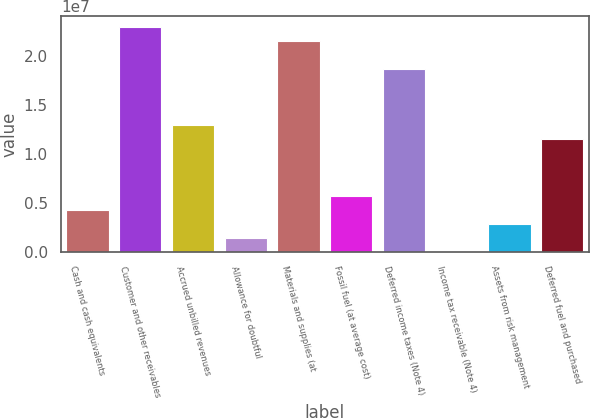Convert chart to OTSL. <chart><loc_0><loc_0><loc_500><loc_500><bar_chart><fcel>Cash and cash equivalents<fcel>Customer and other receivables<fcel>Accrued unbilled revenues<fcel>Allowance for doubtful<fcel>Materials and supplies (at<fcel>Fossil fuel (at average cost)<fcel>Deferred income taxes (Note 4)<fcel>Income tax receivable (Note 4)<fcel>Assets from risk management<fcel>Deferred fuel and purchased<nl><fcel>4.30561e+06<fcel>2.29527e+07<fcel>1.2912e+07<fcel>1.43682e+06<fcel>2.15183e+07<fcel>5.74e+06<fcel>1.86496e+07<fcel>2423<fcel>2.87121e+06<fcel>1.14776e+07<nl></chart> 